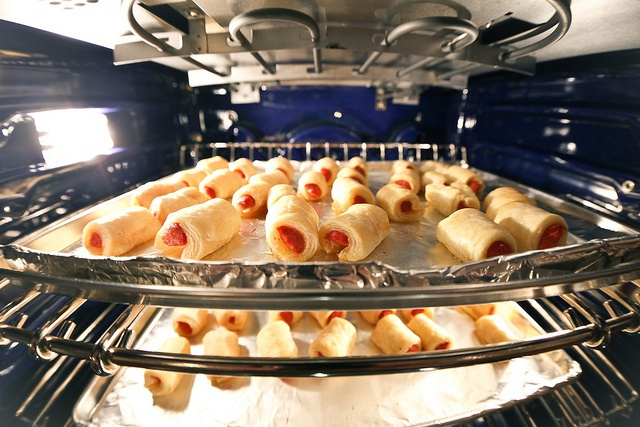Describe the objects in this image and their specific colors. I can see oven in black, ivory, gray, and tan tones, hot dog in ivory, khaki, orange, beige, and black tones, hot dog in ivory, orange, tan, and red tones, hot dog in ivory, khaki, tan, maroon, and olive tones, and hot dog in ivory, tan, red, and brown tones in this image. 